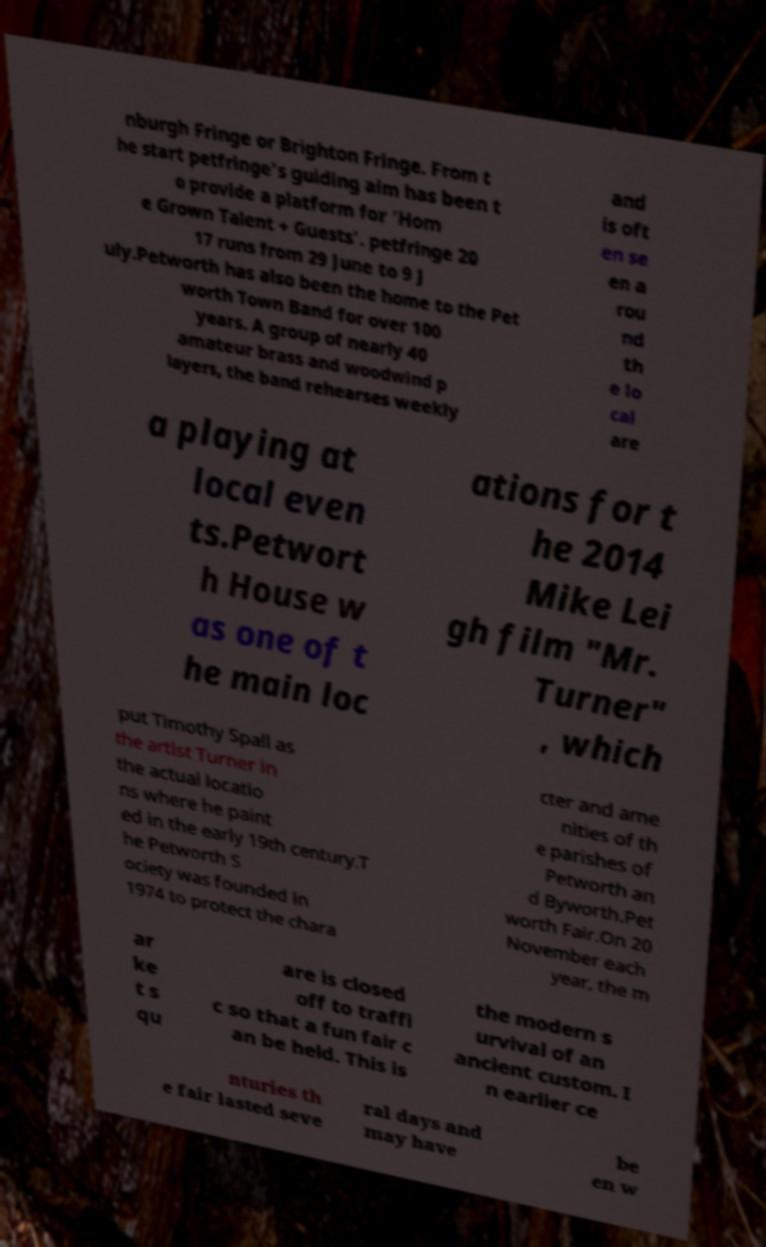Could you assist in decoding the text presented in this image and type it out clearly? nburgh Fringe or Brighton Fringe. From t he start petfringe's guiding aim has been t o provide a platform for 'Hom e Grown Talent + Guests'. petfringe 20 17 runs from 29 June to 9 J uly.Petworth has also been the home to the Pet worth Town Band for over 100 years. A group of nearly 40 amateur brass and woodwind p layers, the band rehearses weekly and is oft en se en a rou nd th e lo cal are a playing at local even ts.Petwort h House w as one of t he main loc ations for t he 2014 Mike Lei gh film "Mr. Turner" , which put Timothy Spall as the artist Turner in the actual locatio ns where he paint ed in the early 19th century.T he Petworth S ociety was founded in 1974 to protect the chara cter and ame nities of th e parishes of Petworth an d Byworth.Pet worth Fair.On 20 November each year, the m ar ke t s qu are is closed off to traffi c so that a fun fair c an be held. This is the modern s urvival of an ancient custom. I n earlier ce nturies th e fair lasted seve ral days and may have be en w 